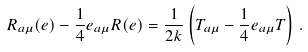<formula> <loc_0><loc_0><loc_500><loc_500>R _ { a \mu } ( e ) - \frac { 1 } { 4 } e _ { a \mu } R ( e ) = \frac { 1 } { 2 k } \left ( T _ { a \mu } - \frac { 1 } { 4 } e _ { a \mu } T \right ) \, .</formula> 